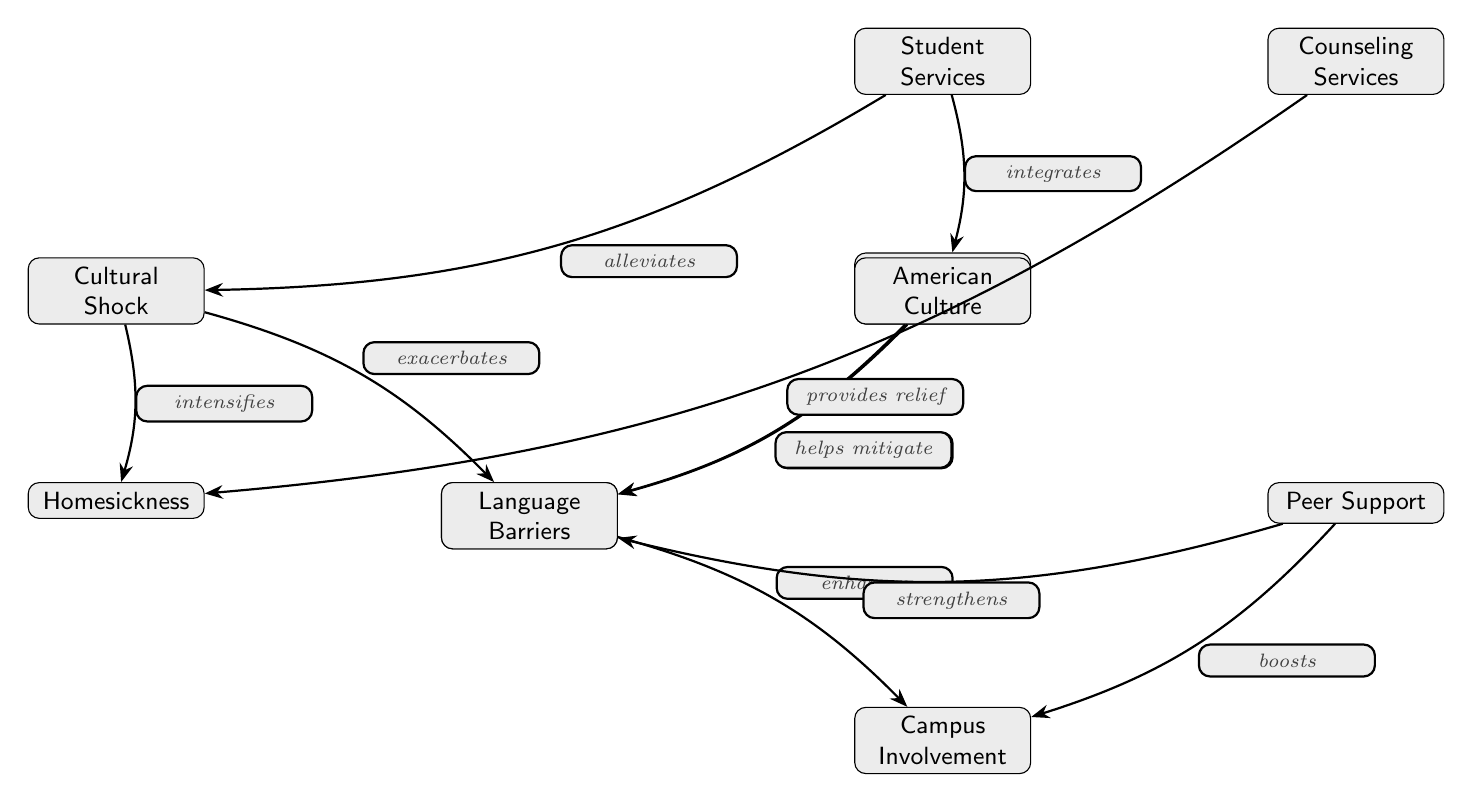What is the central theme of the diagram? The diagram outlines the social integration and cultural adjustment experiences of international students in American universities. The connections illustrate various factors and support systems that impact the adjustment process.
Answer: Social integration and cultural adjustment How many nodes are present in the diagram? The diagram contains eight nodes, each representing a concept related to the experiences of international students. They include cultural shock, social networks, academic support, language barriers, homesickness, campus involvement, student services, counseling services, peer support, and American culture.
Answer: Eight What does cultural shock exacerbate? The diagram illustrates that cultural shock exacerbates language barriers, creating additional challenges for international students.
Answer: Language barriers Which node directly influences social networks? The diagram indicates that American culture has a direct influence on social networks, affecting how international students connect with others.
Answer: American culture What type of support does student services provide? According to the diagram, student services are shown to help mitigate language barriers that international students may face, facilitating their integration.
Answer: Mitigate language barriers How does peer support affect campus involvement? The diagram shows that peer support boosts campus involvement, highlighting the importance of friends and groups in helping international students engage in university life.
Answer: Boosts What are the two effects of cultural shock as illustrated in the diagram? The diagram specifies that cultural shock intensifies homesickness and exacerbates language barriers, showing the negative impact of initial adjustment difficulties.
Answer: Homesickness and language barriers Which node alleviates cultural shock? The diagram depicts that counseling services provide relief from cultural shock, indicating that professional support can assist students in managing their experiences.
Answer: Counseling services What connection exists between academic support and language barriers? The diagram suggests that academic support helps mitigate language barriers, meaning that resources available to students can ease the difficulties caused by language issues.
Answer: Helps mitigate What enhances the effect of social networks? The diagram demonstrates that social networks are enhanced by campus involvement, indicating that being active on campus can strengthen friendships and connections.
Answer: Campus involvement 